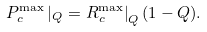<formula> <loc_0><loc_0><loc_500><loc_500>P _ { c } ^ { \max } \left | _ { Q } = R _ { c } ^ { \max } \right | _ { Q } ( 1 - Q ) .</formula> 